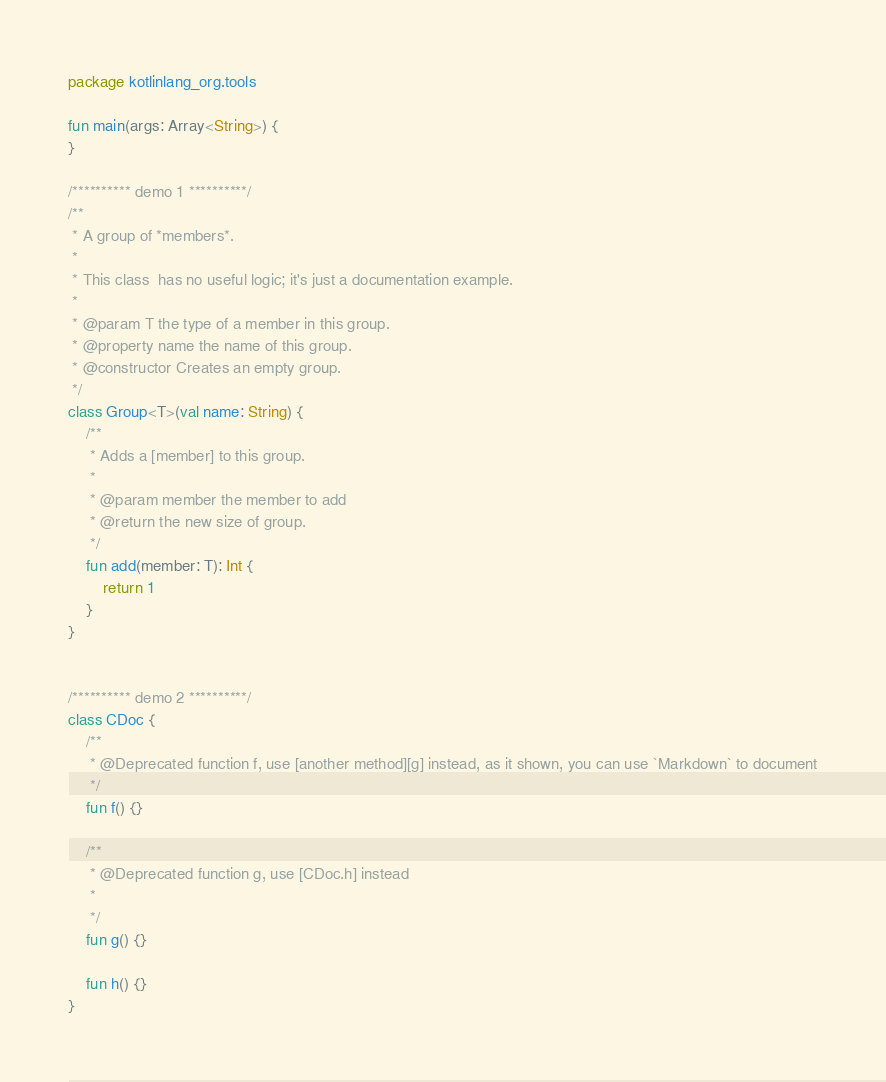Convert code to text. <code><loc_0><loc_0><loc_500><loc_500><_Kotlin_>package kotlinlang_org.tools

fun main(args: Array<String>) {
}

/********** demo 1 **********/
/**
 * A group of *members*.
 *
 * This class  has no useful logic; it's just a documentation example.
 *
 * @param T the type of a member in this group.
 * @property name the name of this group.
 * @constructor Creates an empty group.
 */
class Group<T>(val name: String) {
    /**
     * Adds a [member] to this group.
     *
     * @param member the member to add
     * @return the new size of group.
     */
    fun add(member: T): Int {
        return 1
    }
}


/********** demo 2 **********/
class CDoc {
    /**
     * @Deprecated function f, use [another method][g] instead, as it shown, you can use `Markdown` to document
     */
    fun f() {}

    /**
     * @Deprecated function g, use [CDoc.h] instead
     *
     */
    fun g() {}

    fun h() {}
}</code> 